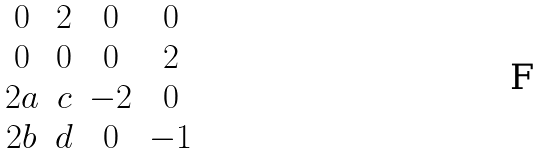Convert formula to latex. <formula><loc_0><loc_0><loc_500><loc_500>\begin{matrix} 0 & 2 & 0 & 0 \\ 0 & 0 & 0 & 2 \\ 2 a & c & - 2 & 0 \\ 2 b & d & 0 & - 1 \end{matrix}</formula> 